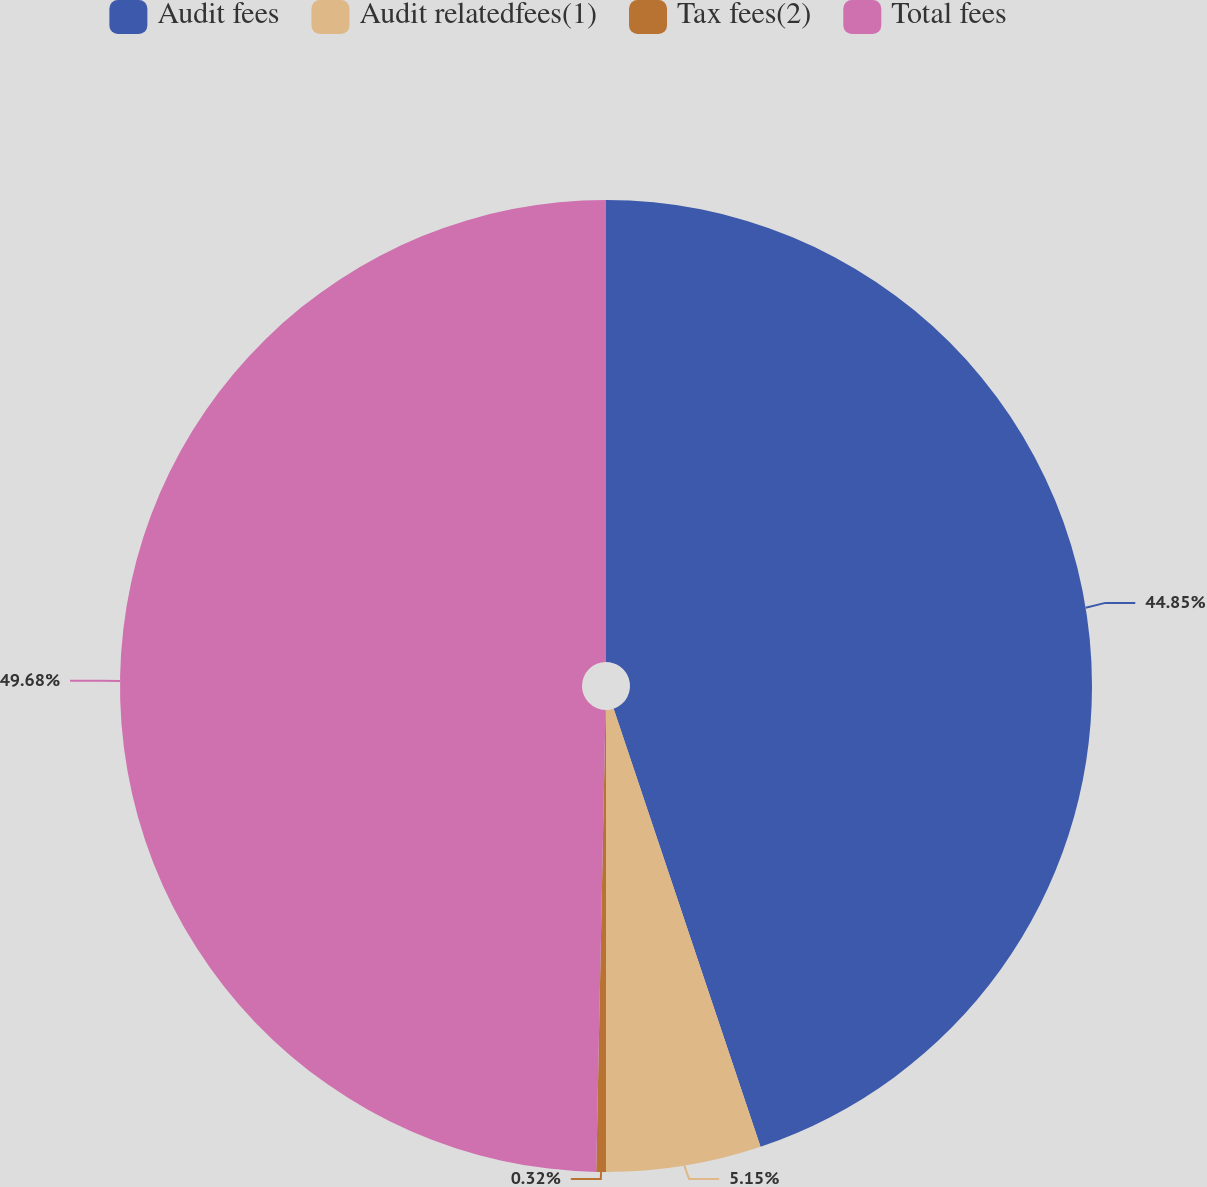Convert chart. <chart><loc_0><loc_0><loc_500><loc_500><pie_chart><fcel>Audit fees<fcel>Audit relatedfees(1)<fcel>Tax fees(2)<fcel>Total fees<nl><fcel>44.85%<fcel>5.15%<fcel>0.32%<fcel>49.68%<nl></chart> 